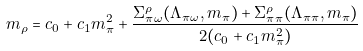Convert formula to latex. <formula><loc_0><loc_0><loc_500><loc_500>m _ { \rho } = c _ { 0 } + c _ { 1 } m _ { \pi } ^ { 2 } + \frac { \Sigma ^ { \rho } _ { \pi \omega } ( \Lambda _ { \pi \omega } , m _ { \pi } ) + \Sigma ^ { \rho } _ { \pi \pi } ( \Lambda _ { \pi \pi } , m _ { \pi } ) } { 2 ( c _ { 0 } + c _ { 1 } m _ { \pi } ^ { 2 } ) }</formula> 